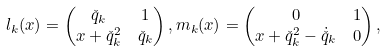Convert formula to latex. <formula><loc_0><loc_0><loc_500><loc_500>& l _ { k } ( x ) = \begin{pmatrix} \check { q } _ { k } & 1 \\ x + \check { q } _ { k } ^ { 2 } & \check { q } _ { k } \end{pmatrix} , m _ { k } ( x ) = \begin{pmatrix} 0 & 1 \\ x + \check { q } _ { k } ^ { 2 } - \dot { \check { q } } _ { k } & 0 \end{pmatrix} ,</formula> 